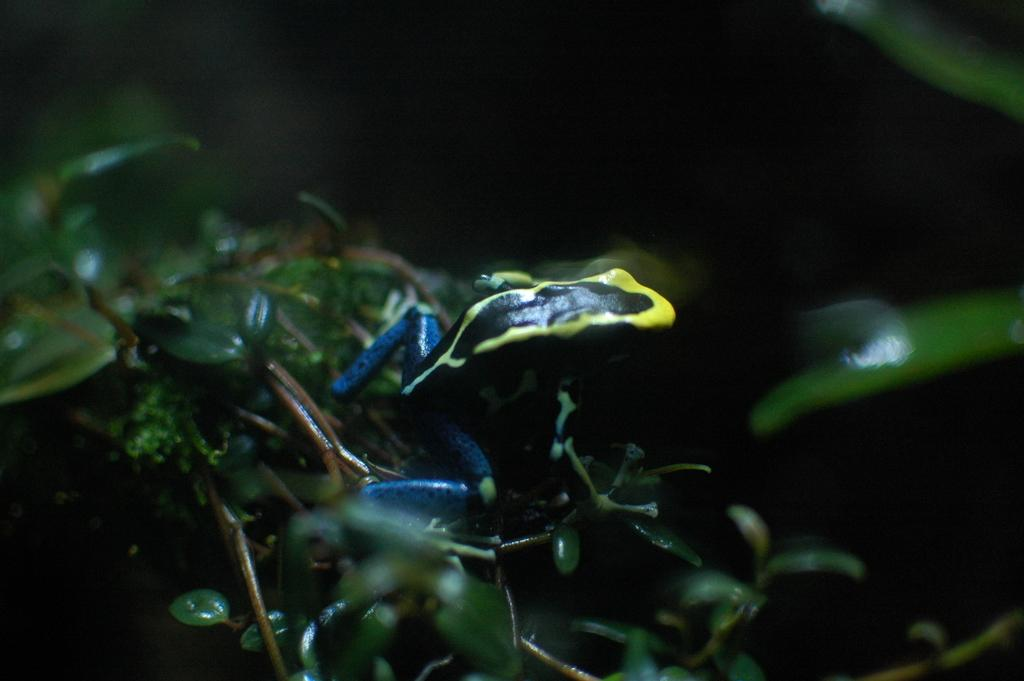What is the overall lighting condition of the image? The image is dark. What type of animal can be seen in the image? There is a frog in the image. What type of plant material is present in the image? There are leaves and stems in the image. What can be observed about the background of the image? The background of the image is also dark. How many balloons are tied to the frog's legs in the image? There are no balloons present in the image; it only features a frog, leaves, and stems. What type of glue is being used to attach the rings to the frog's back in the image? There are no rings or glue present in the image; it only features a frog, leaves, and stems. 